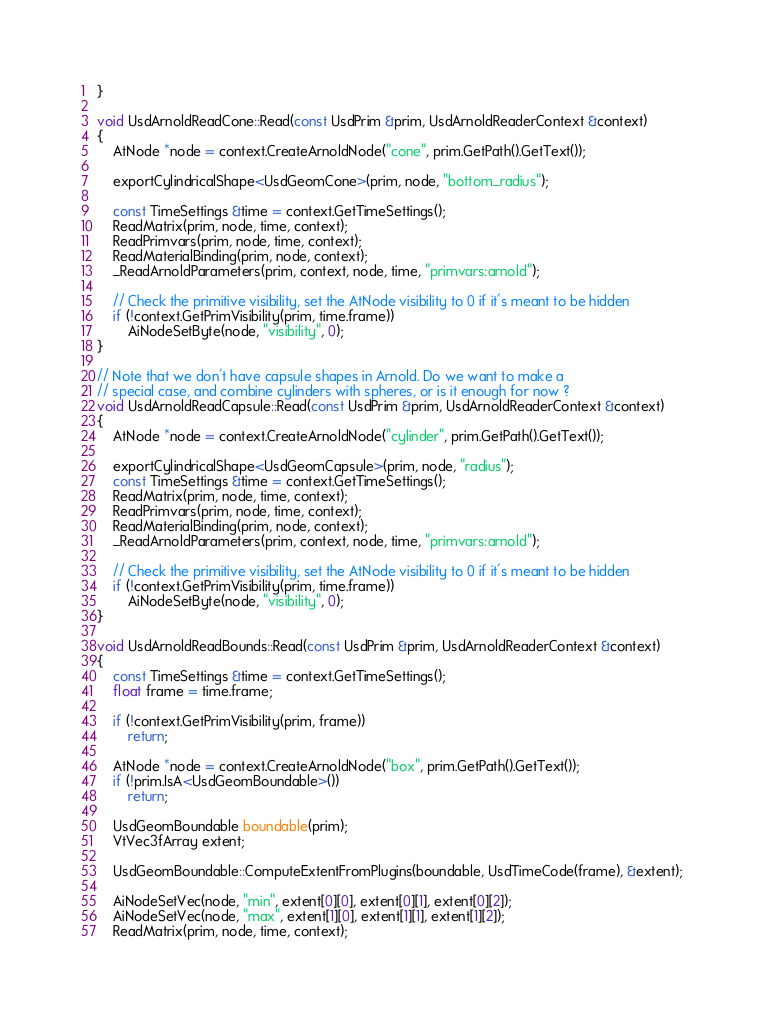<code> <loc_0><loc_0><loc_500><loc_500><_C++_>}

void UsdArnoldReadCone::Read(const UsdPrim &prim, UsdArnoldReaderContext &context)
{
    AtNode *node = context.CreateArnoldNode("cone", prim.GetPath().GetText());

    exportCylindricalShape<UsdGeomCone>(prim, node, "bottom_radius");

    const TimeSettings &time = context.GetTimeSettings();
    ReadMatrix(prim, node, time, context);
    ReadPrimvars(prim, node, time, context);
    ReadMaterialBinding(prim, node, context);
    _ReadArnoldParameters(prim, context, node, time, "primvars:arnold");

    // Check the primitive visibility, set the AtNode visibility to 0 if it's meant to be hidden
    if (!context.GetPrimVisibility(prim, time.frame))
        AiNodeSetByte(node, "visibility", 0);
}

// Note that we don't have capsule shapes in Arnold. Do we want to make a
// special case, and combine cylinders with spheres, or is it enough for now ?
void UsdArnoldReadCapsule::Read(const UsdPrim &prim, UsdArnoldReaderContext &context)
{
    AtNode *node = context.CreateArnoldNode("cylinder", prim.GetPath().GetText());

    exportCylindricalShape<UsdGeomCapsule>(prim, node, "radius");
    const TimeSettings &time = context.GetTimeSettings();
    ReadMatrix(prim, node, time, context);
    ReadPrimvars(prim, node, time, context);
    ReadMaterialBinding(prim, node, context);
    _ReadArnoldParameters(prim, context, node, time, "primvars:arnold");

    // Check the primitive visibility, set the AtNode visibility to 0 if it's meant to be hidden
    if (!context.GetPrimVisibility(prim, time.frame))
        AiNodeSetByte(node, "visibility", 0);
}

void UsdArnoldReadBounds::Read(const UsdPrim &prim, UsdArnoldReaderContext &context)
{
    const TimeSettings &time = context.GetTimeSettings();
    float frame = time.frame;

    if (!context.GetPrimVisibility(prim, frame))
        return;

    AtNode *node = context.CreateArnoldNode("box", prim.GetPath().GetText());
    if (!prim.IsA<UsdGeomBoundable>())
        return;

    UsdGeomBoundable boundable(prim);
    VtVec3fArray extent;

    UsdGeomBoundable::ComputeExtentFromPlugins(boundable, UsdTimeCode(frame), &extent);

    AiNodeSetVec(node, "min", extent[0][0], extent[0][1], extent[0][2]);
    AiNodeSetVec(node, "max", extent[1][0], extent[1][1], extent[1][2]);
    ReadMatrix(prim, node, time, context);
</code> 